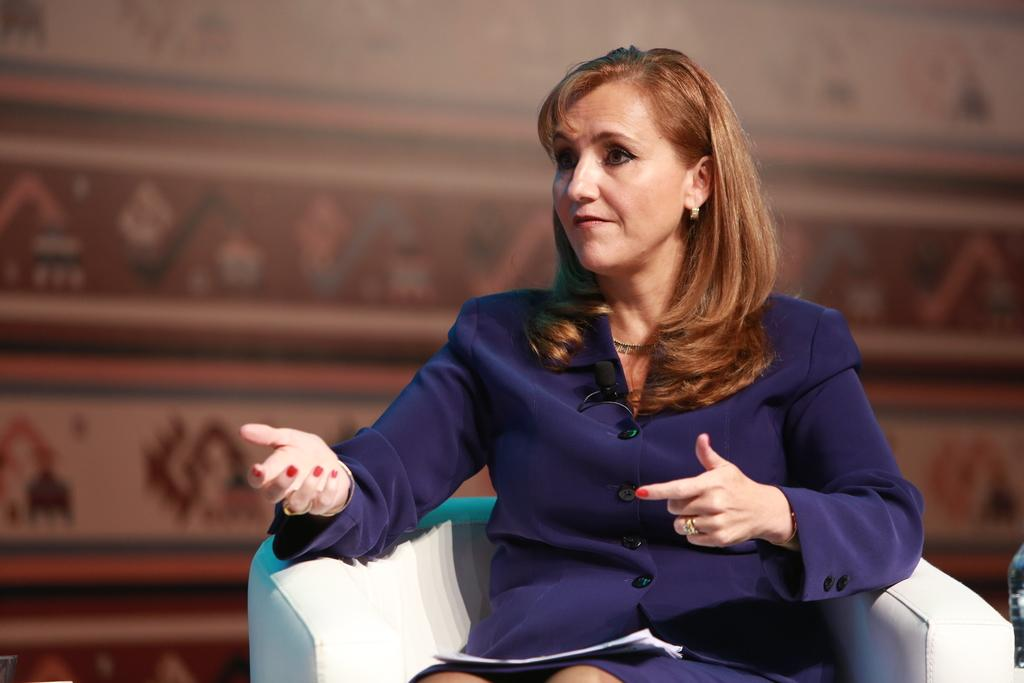Who is the main subject in the image? There is a woman in the image. What is the woman doing in the image? The woman is sitting on a chair and holding some papers. Can you describe the background of the image? The background of the image is blurred. What type of powder is visible on the woman's hands in the image? There is no powder visible on the woman's hands in the image. Are there any giants present in the image? There are no giants present in the image. 